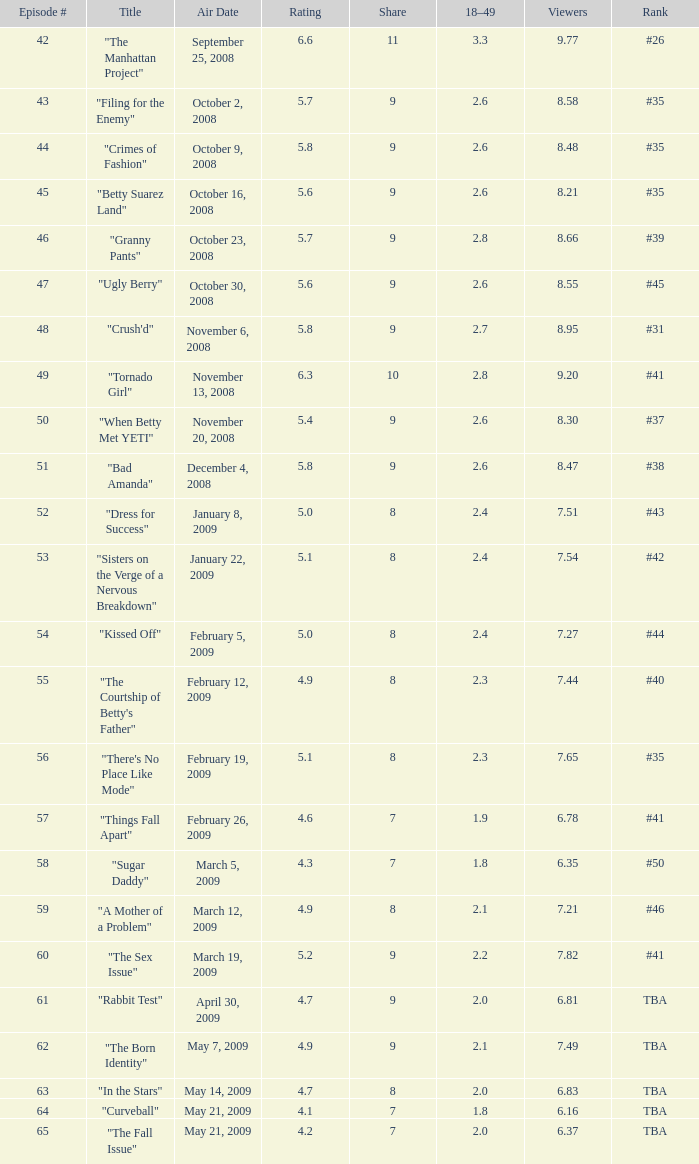What is the average Episode # with a share of 9, and #35 is rank and less than 8.21 viewers? None. 